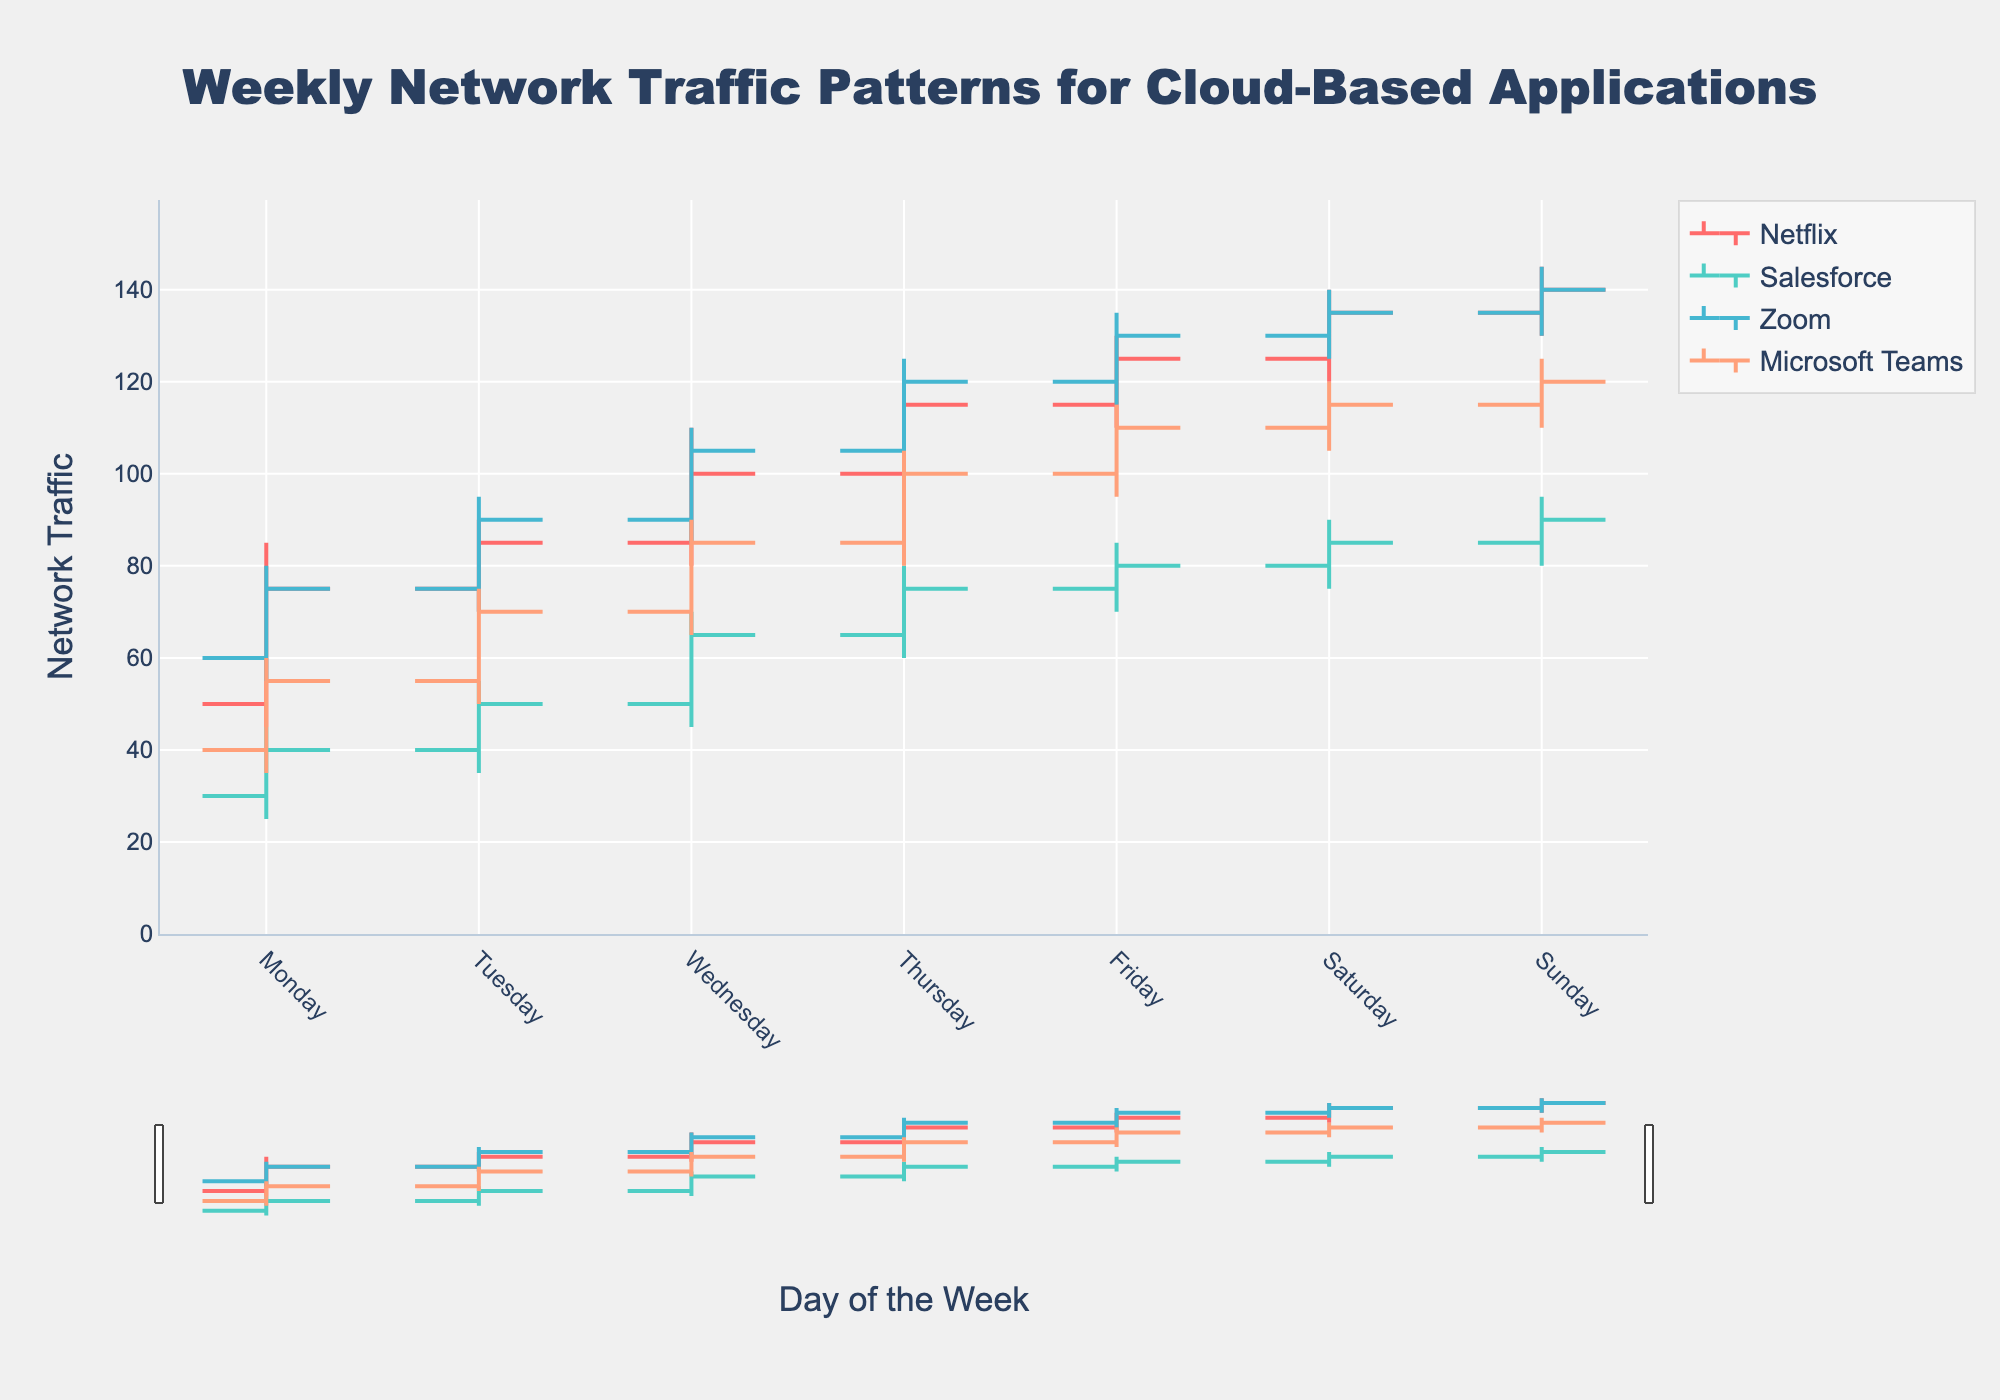What is the title of the chart? The title of the chart is displayed at the top and it reads "Weekly Network Traffic Patterns for Cloud-Based Applications".
Answer: Weekly Network Traffic Patterns for Cloud-Based Applications Which application shows the highest peak on Friday? By looking at the peaks on Friday for all applications, you will see that "Zoom" has the highest peak value of 135.
Answer: Zoom How does Microsoft's network traffic on Tuesday compare to Thursday? On Tuesday, the network traffic for Microsoft Teams ranges from 50 to 75, while on Thursday it ranges from 80 to 105. Thursday has a higher range in comparison.
Answer: Thursday is higher What is the range of network traffic for Netflix on Wednesday? For Wednesday, identify the high and low values for Netflix. The high is 110 and the low is 80, so the range is 110 - 80 = 30.
Answer: 30 Which day has the lowest opening traffic for Salesforce? The figure shows that the lowest opening traffic for Salesforce happens on Monday with an opening value of 30.
Answer: Monday What is the median closing traffic for Netflix across the week? To find the median, list out the closing traffic values for Netflix (75, 85, 100, 115, 125, 135, 140). The middle value in this ordered list is 115.
Answer: 115 How much did Zoom's network traffic increase from Wednesday to Friday? On Wednesday, Zoom's closing traffic is 105 and on Friday, it is 130. The increase is 130 - 105 = 25.
Answer: 25 Which application has the most stable network traffic on Saturday? By comparing the range of high and low values on Saturday for each application, you will see that Microsoft Teams has the smallest range (120 - 105 = 15).
Answer: Microsoft Teams What was the highest traffic recorded for Salesforce? The highest traffic recorded for Salesforce can be found by looking at the highest peak across all days which is 95 on Sunday.
Answer: 95 Is the network traffic for Netflix on Sunday higher or lower than Zoom's traffic on the same day? On Sunday, Netflix's closing traffic is 140 while Zoom's closing traffic is also 140 so they are equal.
Answer: Equal 